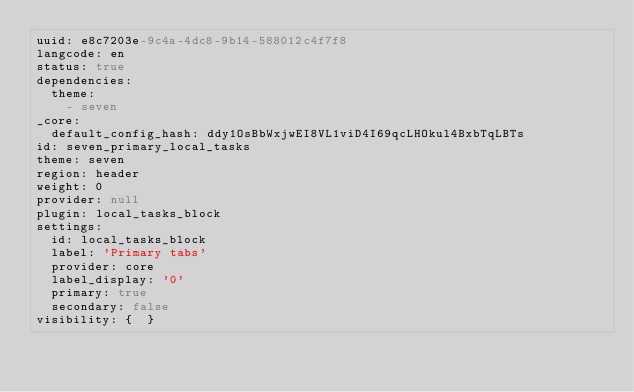Convert code to text. <code><loc_0><loc_0><loc_500><loc_500><_YAML_>uuid: e8c7203e-9c4a-4dc8-9b14-588012c4f7f8
langcode: en
status: true
dependencies:
  theme:
    - seven
_core:
  default_config_hash: ddy1OsBbWxjwEI8VL1viD4I69qcLHOkul4BxbTqLBTs
id: seven_primary_local_tasks
theme: seven
region: header
weight: 0
provider: null
plugin: local_tasks_block
settings:
  id: local_tasks_block
  label: 'Primary tabs'
  provider: core
  label_display: '0'
  primary: true
  secondary: false
visibility: {  }
</code> 